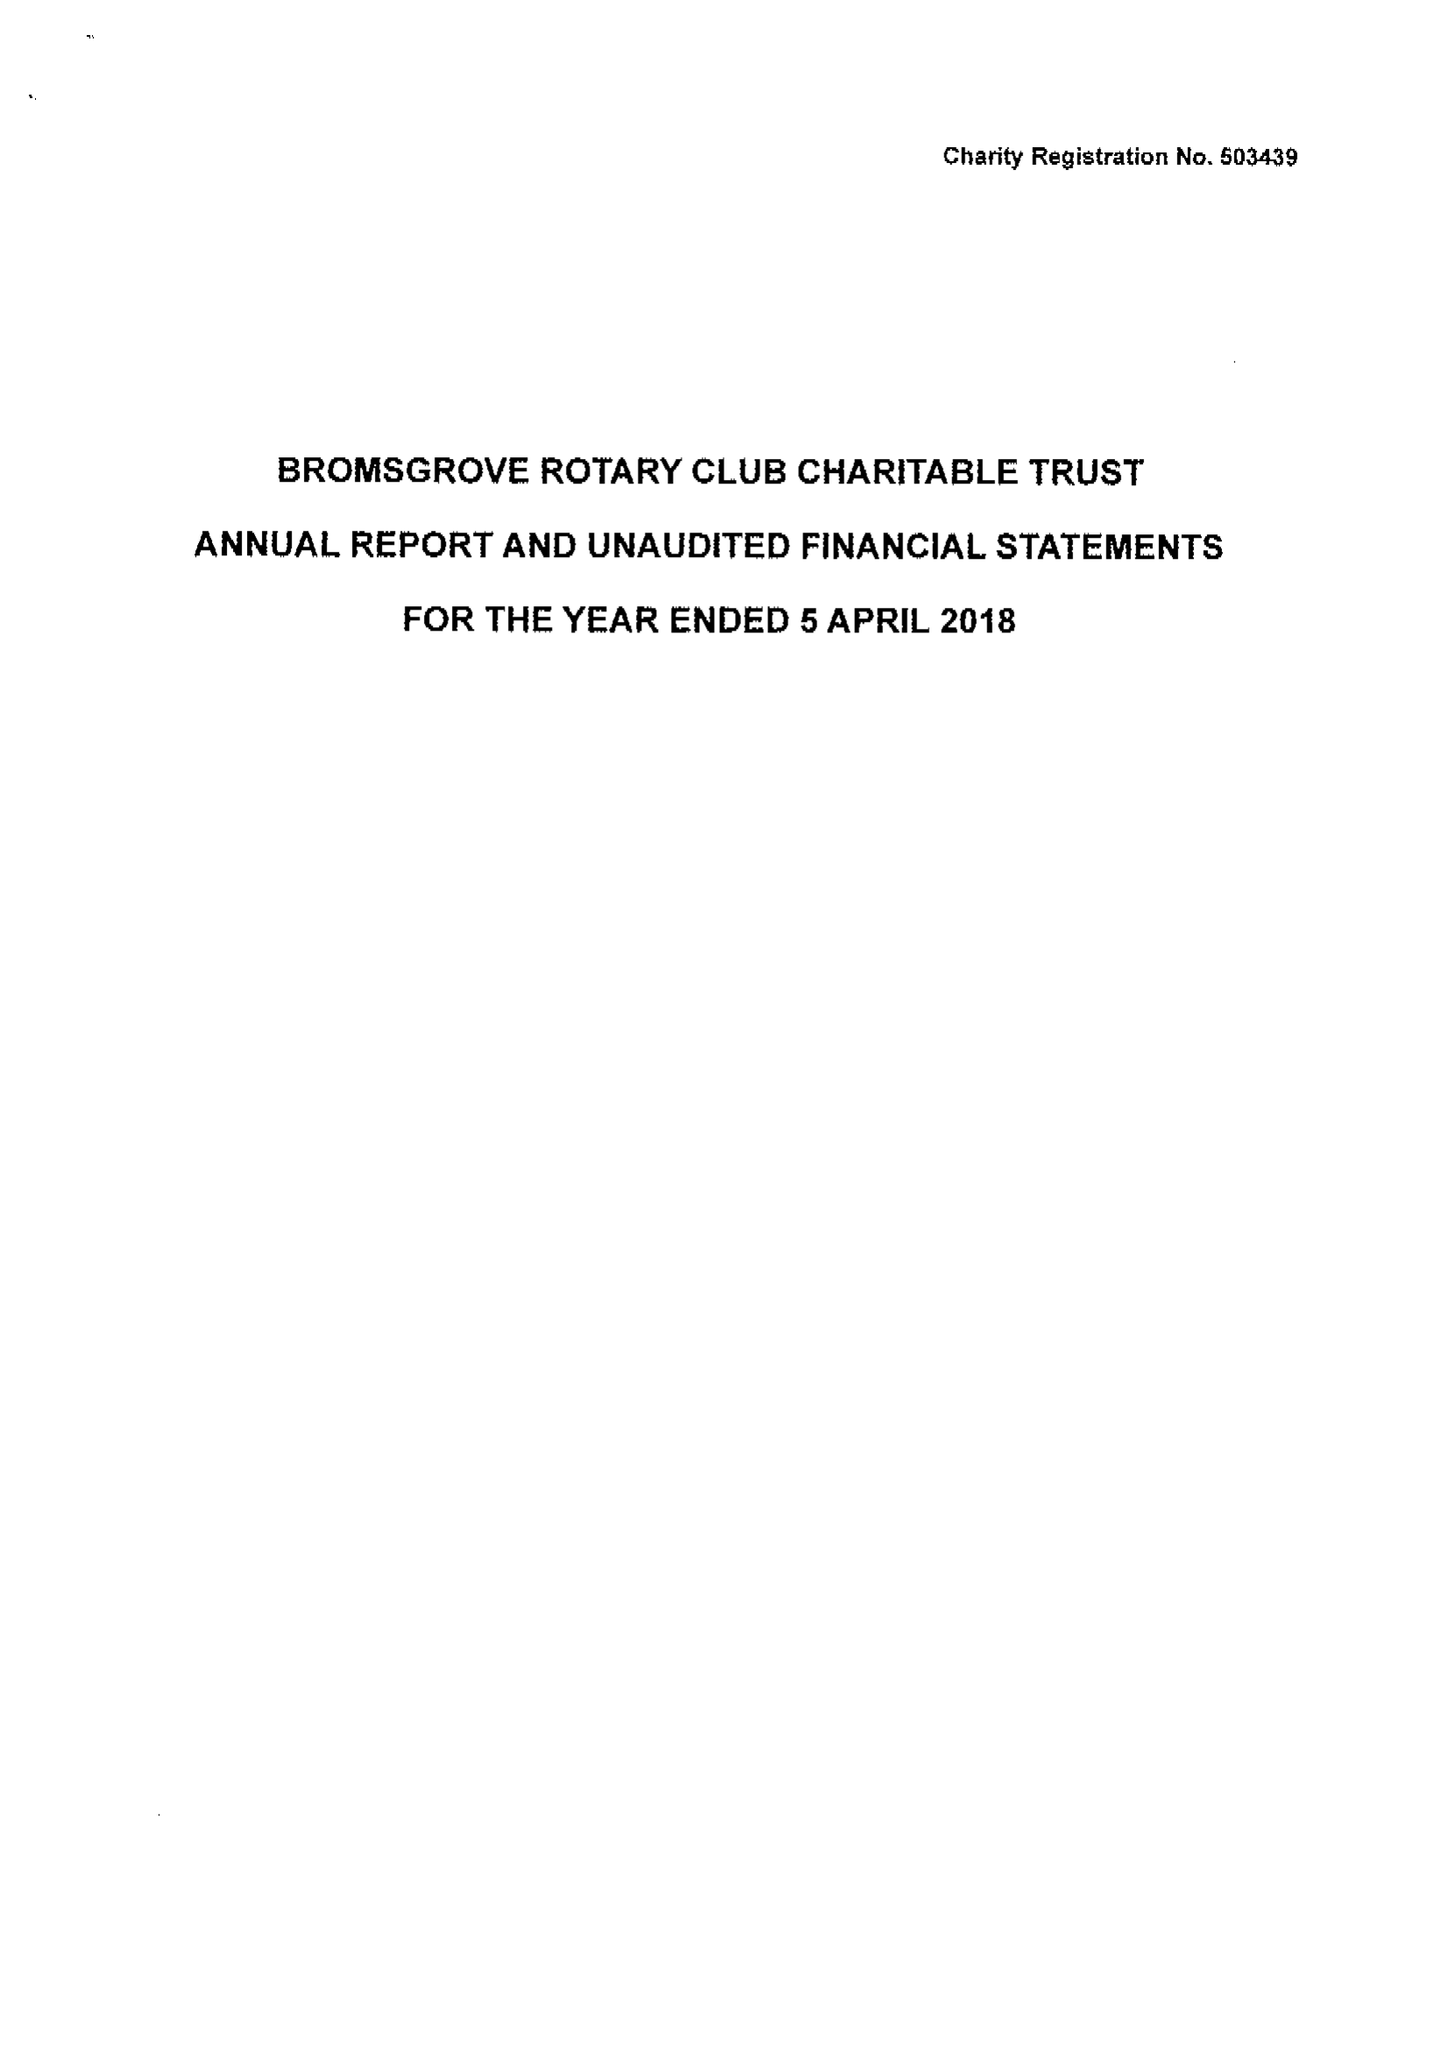What is the value for the address__postcode?
Answer the question using a single word or phrase. B60 1JJ 